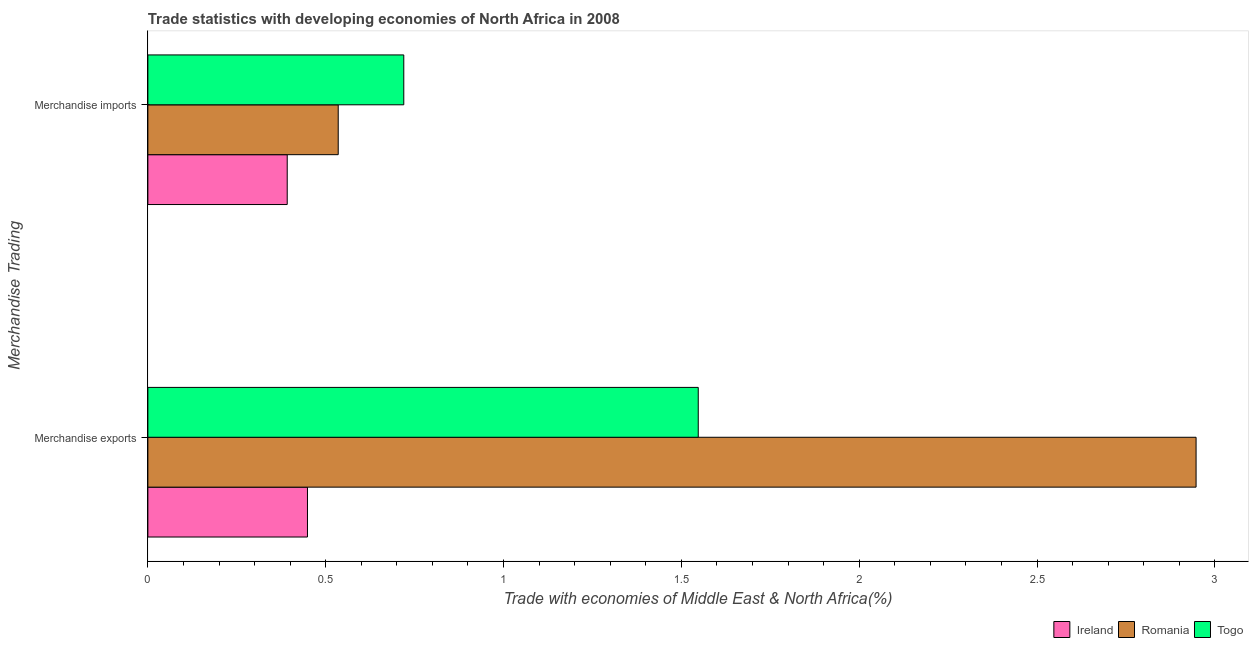How many different coloured bars are there?
Offer a terse response. 3. How many groups of bars are there?
Keep it short and to the point. 2. What is the label of the 1st group of bars from the top?
Your answer should be very brief. Merchandise imports. What is the merchandise imports in Togo?
Keep it short and to the point. 0.72. Across all countries, what is the maximum merchandise exports?
Offer a terse response. 2.95. Across all countries, what is the minimum merchandise imports?
Ensure brevity in your answer.  0.39. In which country was the merchandise exports maximum?
Give a very brief answer. Romania. In which country was the merchandise imports minimum?
Make the answer very short. Ireland. What is the total merchandise exports in the graph?
Your answer should be very brief. 4.94. What is the difference between the merchandise exports in Ireland and that in Togo?
Provide a short and direct response. -1.1. What is the difference between the merchandise exports in Togo and the merchandise imports in Ireland?
Make the answer very short. 1.16. What is the average merchandise exports per country?
Your answer should be very brief. 1.65. What is the difference between the merchandise exports and merchandise imports in Togo?
Provide a short and direct response. 0.83. What is the ratio of the merchandise imports in Romania to that in Togo?
Offer a terse response. 0.74. In how many countries, is the merchandise exports greater than the average merchandise exports taken over all countries?
Keep it short and to the point. 1. What does the 1st bar from the top in Merchandise exports represents?
Provide a short and direct response. Togo. What does the 3rd bar from the bottom in Merchandise exports represents?
Your response must be concise. Togo. How many bars are there?
Provide a succinct answer. 6. How many countries are there in the graph?
Provide a short and direct response. 3. Are the values on the major ticks of X-axis written in scientific E-notation?
Offer a terse response. No. Does the graph contain grids?
Give a very brief answer. No. Where does the legend appear in the graph?
Your answer should be very brief. Bottom right. How many legend labels are there?
Offer a very short reply. 3. How are the legend labels stacked?
Provide a short and direct response. Horizontal. What is the title of the graph?
Your response must be concise. Trade statistics with developing economies of North Africa in 2008. What is the label or title of the X-axis?
Ensure brevity in your answer.  Trade with economies of Middle East & North Africa(%). What is the label or title of the Y-axis?
Provide a short and direct response. Merchandise Trading. What is the Trade with economies of Middle East & North Africa(%) in Ireland in Merchandise exports?
Ensure brevity in your answer.  0.45. What is the Trade with economies of Middle East & North Africa(%) of Romania in Merchandise exports?
Your response must be concise. 2.95. What is the Trade with economies of Middle East & North Africa(%) of Togo in Merchandise exports?
Offer a terse response. 1.55. What is the Trade with economies of Middle East & North Africa(%) of Ireland in Merchandise imports?
Ensure brevity in your answer.  0.39. What is the Trade with economies of Middle East & North Africa(%) of Romania in Merchandise imports?
Your answer should be compact. 0.54. What is the Trade with economies of Middle East & North Africa(%) in Togo in Merchandise imports?
Offer a very short reply. 0.72. Across all Merchandise Trading, what is the maximum Trade with economies of Middle East & North Africa(%) in Ireland?
Make the answer very short. 0.45. Across all Merchandise Trading, what is the maximum Trade with economies of Middle East & North Africa(%) in Romania?
Ensure brevity in your answer.  2.95. Across all Merchandise Trading, what is the maximum Trade with economies of Middle East & North Africa(%) in Togo?
Give a very brief answer. 1.55. Across all Merchandise Trading, what is the minimum Trade with economies of Middle East & North Africa(%) of Ireland?
Your response must be concise. 0.39. Across all Merchandise Trading, what is the minimum Trade with economies of Middle East & North Africa(%) in Romania?
Give a very brief answer. 0.54. Across all Merchandise Trading, what is the minimum Trade with economies of Middle East & North Africa(%) in Togo?
Your answer should be compact. 0.72. What is the total Trade with economies of Middle East & North Africa(%) of Ireland in the graph?
Your answer should be very brief. 0.84. What is the total Trade with economies of Middle East & North Africa(%) of Romania in the graph?
Ensure brevity in your answer.  3.48. What is the total Trade with economies of Middle East & North Africa(%) in Togo in the graph?
Provide a succinct answer. 2.27. What is the difference between the Trade with economies of Middle East & North Africa(%) in Ireland in Merchandise exports and that in Merchandise imports?
Provide a short and direct response. 0.06. What is the difference between the Trade with economies of Middle East & North Africa(%) in Romania in Merchandise exports and that in Merchandise imports?
Offer a terse response. 2.41. What is the difference between the Trade with economies of Middle East & North Africa(%) in Togo in Merchandise exports and that in Merchandise imports?
Offer a very short reply. 0.83. What is the difference between the Trade with economies of Middle East & North Africa(%) in Ireland in Merchandise exports and the Trade with economies of Middle East & North Africa(%) in Romania in Merchandise imports?
Give a very brief answer. -0.09. What is the difference between the Trade with economies of Middle East & North Africa(%) of Ireland in Merchandise exports and the Trade with economies of Middle East & North Africa(%) of Togo in Merchandise imports?
Offer a very short reply. -0.27. What is the difference between the Trade with economies of Middle East & North Africa(%) of Romania in Merchandise exports and the Trade with economies of Middle East & North Africa(%) of Togo in Merchandise imports?
Your response must be concise. 2.23. What is the average Trade with economies of Middle East & North Africa(%) in Ireland per Merchandise Trading?
Provide a short and direct response. 0.42. What is the average Trade with economies of Middle East & North Africa(%) of Romania per Merchandise Trading?
Ensure brevity in your answer.  1.74. What is the average Trade with economies of Middle East & North Africa(%) of Togo per Merchandise Trading?
Your response must be concise. 1.13. What is the difference between the Trade with economies of Middle East & North Africa(%) of Ireland and Trade with economies of Middle East & North Africa(%) of Romania in Merchandise exports?
Give a very brief answer. -2.5. What is the difference between the Trade with economies of Middle East & North Africa(%) of Ireland and Trade with economies of Middle East & North Africa(%) of Togo in Merchandise exports?
Give a very brief answer. -1.1. What is the difference between the Trade with economies of Middle East & North Africa(%) in Romania and Trade with economies of Middle East & North Africa(%) in Togo in Merchandise exports?
Your answer should be compact. 1.4. What is the difference between the Trade with economies of Middle East & North Africa(%) in Ireland and Trade with economies of Middle East & North Africa(%) in Romania in Merchandise imports?
Offer a terse response. -0.14. What is the difference between the Trade with economies of Middle East & North Africa(%) of Ireland and Trade with economies of Middle East & North Africa(%) of Togo in Merchandise imports?
Offer a very short reply. -0.33. What is the difference between the Trade with economies of Middle East & North Africa(%) of Romania and Trade with economies of Middle East & North Africa(%) of Togo in Merchandise imports?
Your answer should be compact. -0.18. What is the ratio of the Trade with economies of Middle East & North Africa(%) in Ireland in Merchandise exports to that in Merchandise imports?
Your answer should be very brief. 1.15. What is the ratio of the Trade with economies of Middle East & North Africa(%) of Romania in Merchandise exports to that in Merchandise imports?
Make the answer very short. 5.51. What is the ratio of the Trade with economies of Middle East & North Africa(%) in Togo in Merchandise exports to that in Merchandise imports?
Provide a short and direct response. 2.15. What is the difference between the highest and the second highest Trade with economies of Middle East & North Africa(%) of Ireland?
Offer a terse response. 0.06. What is the difference between the highest and the second highest Trade with economies of Middle East & North Africa(%) of Romania?
Keep it short and to the point. 2.41. What is the difference between the highest and the second highest Trade with economies of Middle East & North Africa(%) of Togo?
Your answer should be very brief. 0.83. What is the difference between the highest and the lowest Trade with economies of Middle East & North Africa(%) of Ireland?
Give a very brief answer. 0.06. What is the difference between the highest and the lowest Trade with economies of Middle East & North Africa(%) of Romania?
Your answer should be very brief. 2.41. What is the difference between the highest and the lowest Trade with economies of Middle East & North Africa(%) in Togo?
Offer a terse response. 0.83. 